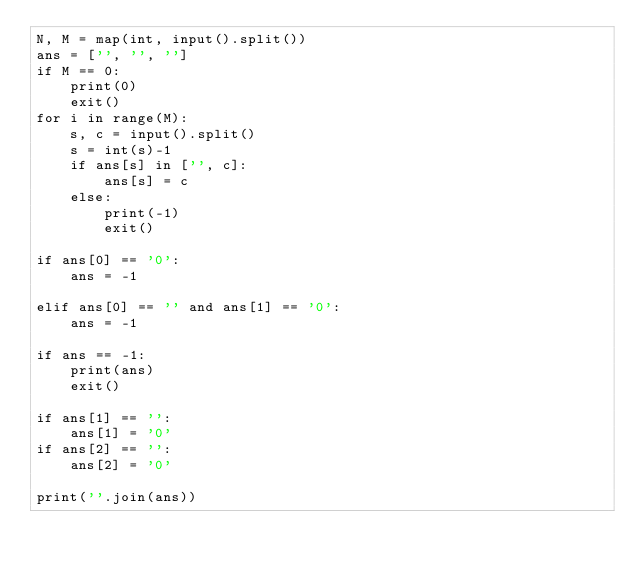Convert code to text. <code><loc_0><loc_0><loc_500><loc_500><_Python_>N, M = map(int, input().split()) 
ans = ['', '', '']
if M == 0:
    print(0)
    exit()
for i in range(M):
    s, c = input().split()
    s = int(s)-1
    if ans[s] in ['', c]:
        ans[s] = c
    else:
        print(-1)
        exit()

if ans[0] == '0':
    ans = -1
 
elif ans[0] == '' and ans[1] == '0':
    ans = -1

if ans == -1:
    print(ans)
    exit()

if ans[1] == '':
    ans[1] = '0'
if ans[2] == '':
    ans[2] = '0'

print(''.join(ans))</code> 